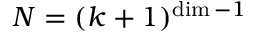<formula> <loc_0><loc_0><loc_500><loc_500>N = ( k + 1 ) ^ { \dim - 1 }</formula> 